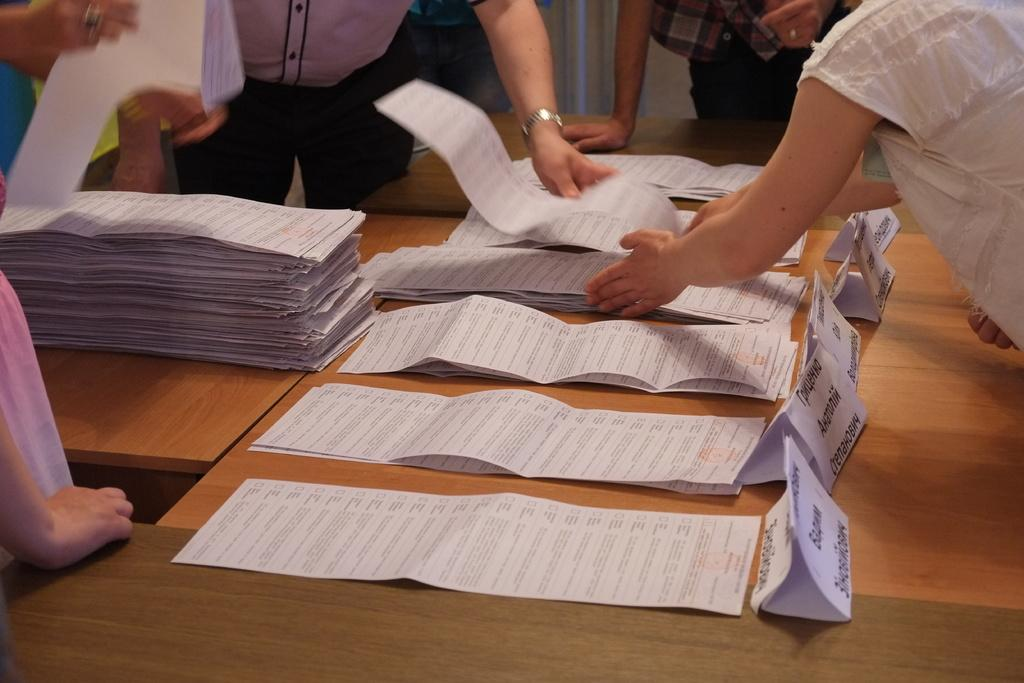What type of furniture is present in the image? There are wooden tables in the image. What is placed on the wooden tables? Papers are placed on the tables. Can you describe the people in the image? There is a group of people standing behind the tables. What type of pin is being used by the expert in the image? There is no pin or expert present in the image. How often do the people in the image brush their teeth with their toothbrushes? There is no toothbrush or reference to brushing teeth in the image. 